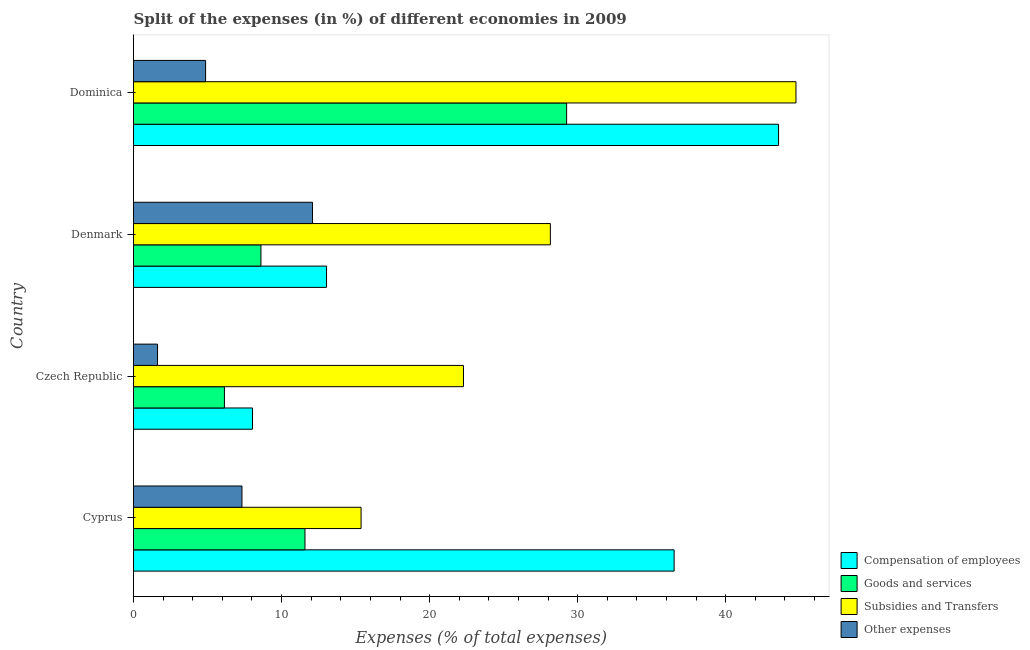How many different coloured bars are there?
Ensure brevity in your answer.  4. Are the number of bars per tick equal to the number of legend labels?
Give a very brief answer. Yes. How many bars are there on the 3rd tick from the top?
Make the answer very short. 4. How many bars are there on the 3rd tick from the bottom?
Your answer should be compact. 4. What is the label of the 3rd group of bars from the top?
Your answer should be compact. Czech Republic. In how many cases, is the number of bars for a given country not equal to the number of legend labels?
Provide a short and direct response. 0. What is the percentage of amount spent on other expenses in Denmark?
Give a very brief answer. 12.09. Across all countries, what is the maximum percentage of amount spent on compensation of employees?
Provide a succinct answer. 43.57. Across all countries, what is the minimum percentage of amount spent on other expenses?
Make the answer very short. 1.62. In which country was the percentage of amount spent on subsidies maximum?
Make the answer very short. Dominica. In which country was the percentage of amount spent on subsidies minimum?
Provide a succinct answer. Cyprus. What is the total percentage of amount spent on other expenses in the graph?
Give a very brief answer. 25.91. What is the difference between the percentage of amount spent on subsidies in Denmark and that in Dominica?
Keep it short and to the point. -16.59. What is the difference between the percentage of amount spent on goods and services in Czech Republic and the percentage of amount spent on compensation of employees in Denmark?
Give a very brief answer. -6.9. What is the average percentage of amount spent on goods and services per country?
Give a very brief answer. 13.9. What is the difference between the percentage of amount spent on other expenses and percentage of amount spent on goods and services in Czech Republic?
Your answer should be very brief. -4.52. What is the ratio of the percentage of amount spent on subsidies in Czech Republic to that in Dominica?
Your answer should be very brief. 0.5. Is the percentage of amount spent on goods and services in Cyprus less than that in Czech Republic?
Your answer should be very brief. No. What is the difference between the highest and the second highest percentage of amount spent on other expenses?
Provide a succinct answer. 4.76. What is the difference between the highest and the lowest percentage of amount spent on compensation of employees?
Give a very brief answer. 35.53. In how many countries, is the percentage of amount spent on compensation of employees greater than the average percentage of amount spent on compensation of employees taken over all countries?
Provide a succinct answer. 2. Is it the case that in every country, the sum of the percentage of amount spent on goods and services and percentage of amount spent on other expenses is greater than the sum of percentage of amount spent on subsidies and percentage of amount spent on compensation of employees?
Your answer should be very brief. No. What does the 3rd bar from the top in Denmark represents?
Make the answer very short. Goods and services. What does the 4th bar from the bottom in Cyprus represents?
Your response must be concise. Other expenses. Is it the case that in every country, the sum of the percentage of amount spent on compensation of employees and percentage of amount spent on goods and services is greater than the percentage of amount spent on subsidies?
Your answer should be compact. No. How many bars are there?
Your answer should be very brief. 16. Are all the bars in the graph horizontal?
Offer a very short reply. Yes. How many countries are there in the graph?
Ensure brevity in your answer.  4. Are the values on the major ticks of X-axis written in scientific E-notation?
Provide a short and direct response. No. Does the graph contain any zero values?
Your answer should be very brief. No. Where does the legend appear in the graph?
Provide a succinct answer. Bottom right. How are the legend labels stacked?
Provide a short and direct response. Vertical. What is the title of the graph?
Your answer should be compact. Split of the expenses (in %) of different economies in 2009. Does "Building human resources" appear as one of the legend labels in the graph?
Provide a succinct answer. No. What is the label or title of the X-axis?
Your response must be concise. Expenses (% of total expenses). What is the Expenses (% of total expenses) of Compensation of employees in Cyprus?
Offer a terse response. 36.52. What is the Expenses (% of total expenses) of Goods and services in Cyprus?
Keep it short and to the point. 11.58. What is the Expenses (% of total expenses) in Subsidies and Transfers in Cyprus?
Your answer should be very brief. 15.37. What is the Expenses (% of total expenses) of Other expenses in Cyprus?
Your response must be concise. 7.33. What is the Expenses (% of total expenses) of Compensation of employees in Czech Republic?
Provide a succinct answer. 8.04. What is the Expenses (% of total expenses) of Goods and services in Czech Republic?
Offer a very short reply. 6.14. What is the Expenses (% of total expenses) of Subsidies and Transfers in Czech Republic?
Offer a very short reply. 22.29. What is the Expenses (% of total expenses) in Other expenses in Czech Republic?
Provide a succinct answer. 1.62. What is the Expenses (% of total expenses) in Compensation of employees in Denmark?
Provide a succinct answer. 13.04. What is the Expenses (% of total expenses) in Goods and services in Denmark?
Provide a succinct answer. 8.61. What is the Expenses (% of total expenses) of Subsidies and Transfers in Denmark?
Offer a terse response. 28.16. What is the Expenses (% of total expenses) of Other expenses in Denmark?
Ensure brevity in your answer.  12.09. What is the Expenses (% of total expenses) in Compensation of employees in Dominica?
Give a very brief answer. 43.57. What is the Expenses (% of total expenses) in Goods and services in Dominica?
Your response must be concise. 29.25. What is the Expenses (% of total expenses) in Subsidies and Transfers in Dominica?
Provide a short and direct response. 44.75. What is the Expenses (% of total expenses) of Other expenses in Dominica?
Offer a very short reply. 4.87. Across all countries, what is the maximum Expenses (% of total expenses) in Compensation of employees?
Provide a short and direct response. 43.57. Across all countries, what is the maximum Expenses (% of total expenses) of Goods and services?
Your response must be concise. 29.25. Across all countries, what is the maximum Expenses (% of total expenses) of Subsidies and Transfers?
Provide a succinct answer. 44.75. Across all countries, what is the maximum Expenses (% of total expenses) of Other expenses?
Provide a short and direct response. 12.09. Across all countries, what is the minimum Expenses (% of total expenses) of Compensation of employees?
Provide a succinct answer. 8.04. Across all countries, what is the minimum Expenses (% of total expenses) in Goods and services?
Provide a short and direct response. 6.14. Across all countries, what is the minimum Expenses (% of total expenses) in Subsidies and Transfers?
Provide a short and direct response. 15.37. Across all countries, what is the minimum Expenses (% of total expenses) of Other expenses?
Provide a short and direct response. 1.62. What is the total Expenses (% of total expenses) in Compensation of employees in the graph?
Keep it short and to the point. 101.16. What is the total Expenses (% of total expenses) of Goods and services in the graph?
Your answer should be very brief. 55.58. What is the total Expenses (% of total expenses) of Subsidies and Transfers in the graph?
Keep it short and to the point. 110.56. What is the total Expenses (% of total expenses) in Other expenses in the graph?
Offer a very short reply. 25.91. What is the difference between the Expenses (% of total expenses) in Compensation of employees in Cyprus and that in Czech Republic?
Ensure brevity in your answer.  28.48. What is the difference between the Expenses (% of total expenses) in Goods and services in Cyprus and that in Czech Republic?
Offer a terse response. 5.44. What is the difference between the Expenses (% of total expenses) of Subsidies and Transfers in Cyprus and that in Czech Republic?
Give a very brief answer. -6.92. What is the difference between the Expenses (% of total expenses) of Other expenses in Cyprus and that in Czech Republic?
Provide a short and direct response. 5.7. What is the difference between the Expenses (% of total expenses) in Compensation of employees in Cyprus and that in Denmark?
Ensure brevity in your answer.  23.48. What is the difference between the Expenses (% of total expenses) of Goods and services in Cyprus and that in Denmark?
Keep it short and to the point. 2.97. What is the difference between the Expenses (% of total expenses) in Subsidies and Transfers in Cyprus and that in Denmark?
Keep it short and to the point. -12.79. What is the difference between the Expenses (% of total expenses) in Other expenses in Cyprus and that in Denmark?
Your response must be concise. -4.76. What is the difference between the Expenses (% of total expenses) in Compensation of employees in Cyprus and that in Dominica?
Your answer should be very brief. -7.05. What is the difference between the Expenses (% of total expenses) in Goods and services in Cyprus and that in Dominica?
Make the answer very short. -17.67. What is the difference between the Expenses (% of total expenses) in Subsidies and Transfers in Cyprus and that in Dominica?
Your answer should be compact. -29.37. What is the difference between the Expenses (% of total expenses) in Other expenses in Cyprus and that in Dominica?
Offer a very short reply. 2.46. What is the difference between the Expenses (% of total expenses) of Compensation of employees in Czech Republic and that in Denmark?
Your answer should be compact. -5. What is the difference between the Expenses (% of total expenses) of Goods and services in Czech Republic and that in Denmark?
Provide a succinct answer. -2.47. What is the difference between the Expenses (% of total expenses) in Subsidies and Transfers in Czech Republic and that in Denmark?
Keep it short and to the point. -5.87. What is the difference between the Expenses (% of total expenses) of Other expenses in Czech Republic and that in Denmark?
Keep it short and to the point. -10.47. What is the difference between the Expenses (% of total expenses) of Compensation of employees in Czech Republic and that in Dominica?
Provide a succinct answer. -35.53. What is the difference between the Expenses (% of total expenses) of Goods and services in Czech Republic and that in Dominica?
Provide a succinct answer. -23.11. What is the difference between the Expenses (% of total expenses) in Subsidies and Transfers in Czech Republic and that in Dominica?
Keep it short and to the point. -22.46. What is the difference between the Expenses (% of total expenses) of Other expenses in Czech Republic and that in Dominica?
Your response must be concise. -3.25. What is the difference between the Expenses (% of total expenses) of Compensation of employees in Denmark and that in Dominica?
Your answer should be very brief. -30.53. What is the difference between the Expenses (% of total expenses) in Goods and services in Denmark and that in Dominica?
Give a very brief answer. -20.65. What is the difference between the Expenses (% of total expenses) of Subsidies and Transfers in Denmark and that in Dominica?
Ensure brevity in your answer.  -16.59. What is the difference between the Expenses (% of total expenses) in Other expenses in Denmark and that in Dominica?
Provide a short and direct response. 7.22. What is the difference between the Expenses (% of total expenses) in Compensation of employees in Cyprus and the Expenses (% of total expenses) in Goods and services in Czech Republic?
Offer a terse response. 30.38. What is the difference between the Expenses (% of total expenses) of Compensation of employees in Cyprus and the Expenses (% of total expenses) of Subsidies and Transfers in Czech Republic?
Offer a terse response. 14.23. What is the difference between the Expenses (% of total expenses) of Compensation of employees in Cyprus and the Expenses (% of total expenses) of Other expenses in Czech Republic?
Your answer should be compact. 34.89. What is the difference between the Expenses (% of total expenses) in Goods and services in Cyprus and the Expenses (% of total expenses) in Subsidies and Transfers in Czech Republic?
Your answer should be very brief. -10.71. What is the difference between the Expenses (% of total expenses) of Goods and services in Cyprus and the Expenses (% of total expenses) of Other expenses in Czech Republic?
Your response must be concise. 9.96. What is the difference between the Expenses (% of total expenses) of Subsidies and Transfers in Cyprus and the Expenses (% of total expenses) of Other expenses in Czech Republic?
Provide a short and direct response. 13.75. What is the difference between the Expenses (% of total expenses) in Compensation of employees in Cyprus and the Expenses (% of total expenses) in Goods and services in Denmark?
Make the answer very short. 27.91. What is the difference between the Expenses (% of total expenses) in Compensation of employees in Cyprus and the Expenses (% of total expenses) in Subsidies and Transfers in Denmark?
Keep it short and to the point. 8.36. What is the difference between the Expenses (% of total expenses) in Compensation of employees in Cyprus and the Expenses (% of total expenses) in Other expenses in Denmark?
Keep it short and to the point. 24.43. What is the difference between the Expenses (% of total expenses) of Goods and services in Cyprus and the Expenses (% of total expenses) of Subsidies and Transfers in Denmark?
Your answer should be compact. -16.57. What is the difference between the Expenses (% of total expenses) in Goods and services in Cyprus and the Expenses (% of total expenses) in Other expenses in Denmark?
Your answer should be very brief. -0.51. What is the difference between the Expenses (% of total expenses) of Subsidies and Transfers in Cyprus and the Expenses (% of total expenses) of Other expenses in Denmark?
Your response must be concise. 3.28. What is the difference between the Expenses (% of total expenses) in Compensation of employees in Cyprus and the Expenses (% of total expenses) in Goods and services in Dominica?
Keep it short and to the point. 7.26. What is the difference between the Expenses (% of total expenses) of Compensation of employees in Cyprus and the Expenses (% of total expenses) of Subsidies and Transfers in Dominica?
Your response must be concise. -8.23. What is the difference between the Expenses (% of total expenses) in Compensation of employees in Cyprus and the Expenses (% of total expenses) in Other expenses in Dominica?
Your answer should be compact. 31.65. What is the difference between the Expenses (% of total expenses) in Goods and services in Cyprus and the Expenses (% of total expenses) in Subsidies and Transfers in Dominica?
Provide a short and direct response. -33.16. What is the difference between the Expenses (% of total expenses) in Goods and services in Cyprus and the Expenses (% of total expenses) in Other expenses in Dominica?
Provide a short and direct response. 6.71. What is the difference between the Expenses (% of total expenses) in Subsidies and Transfers in Cyprus and the Expenses (% of total expenses) in Other expenses in Dominica?
Your answer should be very brief. 10.5. What is the difference between the Expenses (% of total expenses) in Compensation of employees in Czech Republic and the Expenses (% of total expenses) in Goods and services in Denmark?
Your response must be concise. -0.57. What is the difference between the Expenses (% of total expenses) of Compensation of employees in Czech Republic and the Expenses (% of total expenses) of Subsidies and Transfers in Denmark?
Ensure brevity in your answer.  -20.12. What is the difference between the Expenses (% of total expenses) of Compensation of employees in Czech Republic and the Expenses (% of total expenses) of Other expenses in Denmark?
Make the answer very short. -4.05. What is the difference between the Expenses (% of total expenses) in Goods and services in Czech Republic and the Expenses (% of total expenses) in Subsidies and Transfers in Denmark?
Keep it short and to the point. -22.02. What is the difference between the Expenses (% of total expenses) in Goods and services in Czech Republic and the Expenses (% of total expenses) in Other expenses in Denmark?
Ensure brevity in your answer.  -5.95. What is the difference between the Expenses (% of total expenses) in Subsidies and Transfers in Czech Republic and the Expenses (% of total expenses) in Other expenses in Denmark?
Your answer should be very brief. 10.2. What is the difference between the Expenses (% of total expenses) in Compensation of employees in Czech Republic and the Expenses (% of total expenses) in Goods and services in Dominica?
Provide a succinct answer. -21.22. What is the difference between the Expenses (% of total expenses) in Compensation of employees in Czech Republic and the Expenses (% of total expenses) in Subsidies and Transfers in Dominica?
Ensure brevity in your answer.  -36.71. What is the difference between the Expenses (% of total expenses) of Compensation of employees in Czech Republic and the Expenses (% of total expenses) of Other expenses in Dominica?
Keep it short and to the point. 3.17. What is the difference between the Expenses (% of total expenses) of Goods and services in Czech Republic and the Expenses (% of total expenses) of Subsidies and Transfers in Dominica?
Provide a short and direct response. -38.61. What is the difference between the Expenses (% of total expenses) of Goods and services in Czech Republic and the Expenses (% of total expenses) of Other expenses in Dominica?
Make the answer very short. 1.27. What is the difference between the Expenses (% of total expenses) of Subsidies and Transfers in Czech Republic and the Expenses (% of total expenses) of Other expenses in Dominica?
Keep it short and to the point. 17.42. What is the difference between the Expenses (% of total expenses) of Compensation of employees in Denmark and the Expenses (% of total expenses) of Goods and services in Dominica?
Make the answer very short. -16.22. What is the difference between the Expenses (% of total expenses) in Compensation of employees in Denmark and the Expenses (% of total expenses) in Subsidies and Transfers in Dominica?
Keep it short and to the point. -31.71. What is the difference between the Expenses (% of total expenses) of Compensation of employees in Denmark and the Expenses (% of total expenses) of Other expenses in Dominica?
Offer a very short reply. 8.17. What is the difference between the Expenses (% of total expenses) of Goods and services in Denmark and the Expenses (% of total expenses) of Subsidies and Transfers in Dominica?
Provide a succinct answer. -36.14. What is the difference between the Expenses (% of total expenses) of Goods and services in Denmark and the Expenses (% of total expenses) of Other expenses in Dominica?
Offer a terse response. 3.74. What is the difference between the Expenses (% of total expenses) of Subsidies and Transfers in Denmark and the Expenses (% of total expenses) of Other expenses in Dominica?
Make the answer very short. 23.29. What is the average Expenses (% of total expenses) in Compensation of employees per country?
Make the answer very short. 25.29. What is the average Expenses (% of total expenses) of Goods and services per country?
Your answer should be compact. 13.9. What is the average Expenses (% of total expenses) in Subsidies and Transfers per country?
Your response must be concise. 27.64. What is the average Expenses (% of total expenses) of Other expenses per country?
Give a very brief answer. 6.48. What is the difference between the Expenses (% of total expenses) of Compensation of employees and Expenses (% of total expenses) of Goods and services in Cyprus?
Keep it short and to the point. 24.93. What is the difference between the Expenses (% of total expenses) of Compensation of employees and Expenses (% of total expenses) of Subsidies and Transfers in Cyprus?
Keep it short and to the point. 21.14. What is the difference between the Expenses (% of total expenses) in Compensation of employees and Expenses (% of total expenses) in Other expenses in Cyprus?
Your answer should be very brief. 29.19. What is the difference between the Expenses (% of total expenses) of Goods and services and Expenses (% of total expenses) of Subsidies and Transfers in Cyprus?
Give a very brief answer. -3.79. What is the difference between the Expenses (% of total expenses) in Goods and services and Expenses (% of total expenses) in Other expenses in Cyprus?
Your answer should be very brief. 4.25. What is the difference between the Expenses (% of total expenses) of Subsidies and Transfers and Expenses (% of total expenses) of Other expenses in Cyprus?
Your answer should be compact. 8.04. What is the difference between the Expenses (% of total expenses) in Compensation of employees and Expenses (% of total expenses) in Goods and services in Czech Republic?
Provide a short and direct response. 1.9. What is the difference between the Expenses (% of total expenses) in Compensation of employees and Expenses (% of total expenses) in Subsidies and Transfers in Czech Republic?
Make the answer very short. -14.25. What is the difference between the Expenses (% of total expenses) of Compensation of employees and Expenses (% of total expenses) of Other expenses in Czech Republic?
Your response must be concise. 6.42. What is the difference between the Expenses (% of total expenses) of Goods and services and Expenses (% of total expenses) of Subsidies and Transfers in Czech Republic?
Offer a terse response. -16.15. What is the difference between the Expenses (% of total expenses) in Goods and services and Expenses (% of total expenses) in Other expenses in Czech Republic?
Give a very brief answer. 4.52. What is the difference between the Expenses (% of total expenses) of Subsidies and Transfers and Expenses (% of total expenses) of Other expenses in Czech Republic?
Ensure brevity in your answer.  20.66. What is the difference between the Expenses (% of total expenses) of Compensation of employees and Expenses (% of total expenses) of Goods and services in Denmark?
Give a very brief answer. 4.43. What is the difference between the Expenses (% of total expenses) of Compensation of employees and Expenses (% of total expenses) of Subsidies and Transfers in Denmark?
Give a very brief answer. -15.12. What is the difference between the Expenses (% of total expenses) in Compensation of employees and Expenses (% of total expenses) in Other expenses in Denmark?
Provide a succinct answer. 0.95. What is the difference between the Expenses (% of total expenses) of Goods and services and Expenses (% of total expenses) of Subsidies and Transfers in Denmark?
Your answer should be very brief. -19.55. What is the difference between the Expenses (% of total expenses) of Goods and services and Expenses (% of total expenses) of Other expenses in Denmark?
Ensure brevity in your answer.  -3.48. What is the difference between the Expenses (% of total expenses) of Subsidies and Transfers and Expenses (% of total expenses) of Other expenses in Denmark?
Keep it short and to the point. 16.07. What is the difference between the Expenses (% of total expenses) of Compensation of employees and Expenses (% of total expenses) of Goods and services in Dominica?
Offer a terse response. 14.32. What is the difference between the Expenses (% of total expenses) in Compensation of employees and Expenses (% of total expenses) in Subsidies and Transfers in Dominica?
Offer a terse response. -1.18. What is the difference between the Expenses (% of total expenses) in Compensation of employees and Expenses (% of total expenses) in Other expenses in Dominica?
Give a very brief answer. 38.7. What is the difference between the Expenses (% of total expenses) in Goods and services and Expenses (% of total expenses) in Subsidies and Transfers in Dominica?
Ensure brevity in your answer.  -15.49. What is the difference between the Expenses (% of total expenses) in Goods and services and Expenses (% of total expenses) in Other expenses in Dominica?
Provide a succinct answer. 24.39. What is the difference between the Expenses (% of total expenses) in Subsidies and Transfers and Expenses (% of total expenses) in Other expenses in Dominica?
Your response must be concise. 39.88. What is the ratio of the Expenses (% of total expenses) in Compensation of employees in Cyprus to that in Czech Republic?
Provide a short and direct response. 4.54. What is the ratio of the Expenses (% of total expenses) of Goods and services in Cyprus to that in Czech Republic?
Your answer should be compact. 1.89. What is the ratio of the Expenses (% of total expenses) in Subsidies and Transfers in Cyprus to that in Czech Republic?
Provide a short and direct response. 0.69. What is the ratio of the Expenses (% of total expenses) in Other expenses in Cyprus to that in Czech Republic?
Provide a short and direct response. 4.51. What is the ratio of the Expenses (% of total expenses) of Compensation of employees in Cyprus to that in Denmark?
Your response must be concise. 2.8. What is the ratio of the Expenses (% of total expenses) of Goods and services in Cyprus to that in Denmark?
Your response must be concise. 1.35. What is the ratio of the Expenses (% of total expenses) in Subsidies and Transfers in Cyprus to that in Denmark?
Your answer should be compact. 0.55. What is the ratio of the Expenses (% of total expenses) of Other expenses in Cyprus to that in Denmark?
Keep it short and to the point. 0.61. What is the ratio of the Expenses (% of total expenses) in Compensation of employees in Cyprus to that in Dominica?
Provide a succinct answer. 0.84. What is the ratio of the Expenses (% of total expenses) in Goods and services in Cyprus to that in Dominica?
Your answer should be very brief. 0.4. What is the ratio of the Expenses (% of total expenses) in Subsidies and Transfers in Cyprus to that in Dominica?
Keep it short and to the point. 0.34. What is the ratio of the Expenses (% of total expenses) of Other expenses in Cyprus to that in Dominica?
Provide a short and direct response. 1.5. What is the ratio of the Expenses (% of total expenses) in Compensation of employees in Czech Republic to that in Denmark?
Keep it short and to the point. 0.62. What is the ratio of the Expenses (% of total expenses) in Goods and services in Czech Republic to that in Denmark?
Your answer should be compact. 0.71. What is the ratio of the Expenses (% of total expenses) in Subsidies and Transfers in Czech Republic to that in Denmark?
Ensure brevity in your answer.  0.79. What is the ratio of the Expenses (% of total expenses) of Other expenses in Czech Republic to that in Denmark?
Your answer should be very brief. 0.13. What is the ratio of the Expenses (% of total expenses) of Compensation of employees in Czech Republic to that in Dominica?
Your answer should be compact. 0.18. What is the ratio of the Expenses (% of total expenses) of Goods and services in Czech Republic to that in Dominica?
Provide a succinct answer. 0.21. What is the ratio of the Expenses (% of total expenses) in Subsidies and Transfers in Czech Republic to that in Dominica?
Your answer should be very brief. 0.5. What is the ratio of the Expenses (% of total expenses) of Compensation of employees in Denmark to that in Dominica?
Offer a terse response. 0.3. What is the ratio of the Expenses (% of total expenses) in Goods and services in Denmark to that in Dominica?
Ensure brevity in your answer.  0.29. What is the ratio of the Expenses (% of total expenses) in Subsidies and Transfers in Denmark to that in Dominica?
Offer a very short reply. 0.63. What is the ratio of the Expenses (% of total expenses) of Other expenses in Denmark to that in Dominica?
Your answer should be very brief. 2.48. What is the difference between the highest and the second highest Expenses (% of total expenses) in Compensation of employees?
Your response must be concise. 7.05. What is the difference between the highest and the second highest Expenses (% of total expenses) of Goods and services?
Your answer should be compact. 17.67. What is the difference between the highest and the second highest Expenses (% of total expenses) of Subsidies and Transfers?
Your response must be concise. 16.59. What is the difference between the highest and the second highest Expenses (% of total expenses) of Other expenses?
Your response must be concise. 4.76. What is the difference between the highest and the lowest Expenses (% of total expenses) of Compensation of employees?
Keep it short and to the point. 35.53. What is the difference between the highest and the lowest Expenses (% of total expenses) in Goods and services?
Your answer should be very brief. 23.11. What is the difference between the highest and the lowest Expenses (% of total expenses) of Subsidies and Transfers?
Make the answer very short. 29.37. What is the difference between the highest and the lowest Expenses (% of total expenses) of Other expenses?
Offer a terse response. 10.47. 